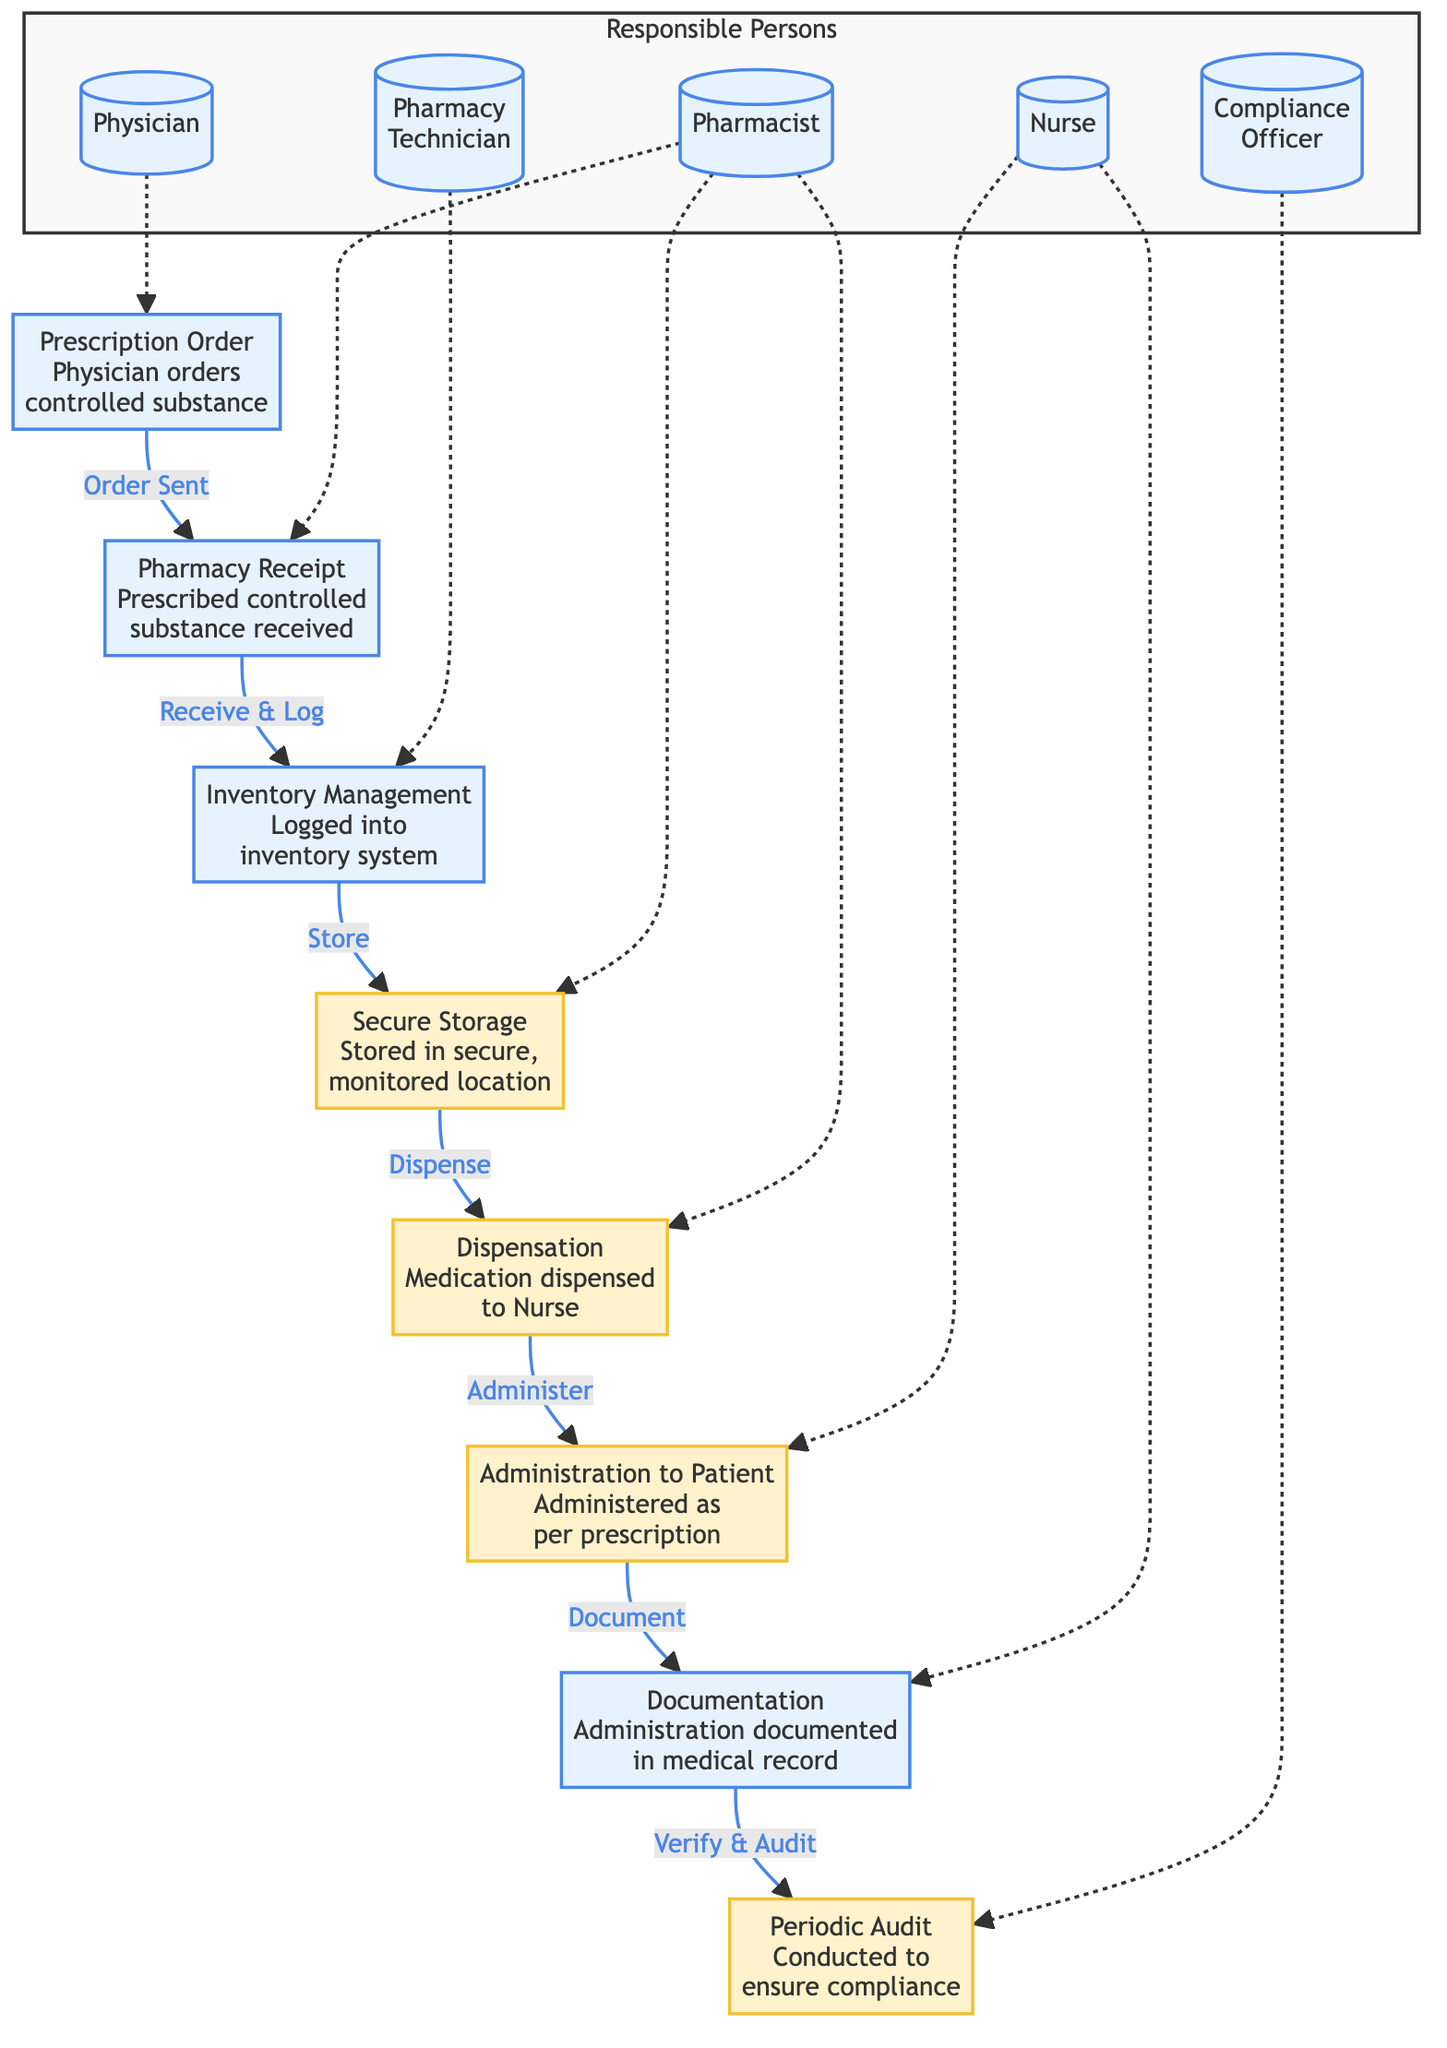What is the first step in the chain of custody? The first step in the chain of custody is the "Prescription Order," which occurs when a physician orders a controlled substance. This is indicated as the starting point in the diagram.
Answer: Prescription Order Who is responsible for the Pharmacy Receipt step? The "Pharmacy Receipt" step is indicated as being managed by the "Pharmacist" according to the responsible persons in the diagram.
Answer: Pharmacist How many nodes are in the diagram? By counting each distinct box in the provided diagram, there are a total of 8 nodes representing different steps in the chain of custody for controlled substances.
Answer: 8 What security measures are implemented during storage? The storage step is highlighted as "Secure Storage," indicating that the controlled substances are stored in a secure and monitored location, which is a security measure.
Answer: Stored in secure, monitored location Which step follows the Dispensation step? According to the flow of the diagram, after the "Dispensation" step, the next step is "Administration to Patient," where the medication is administered according to the prescription.
Answer: Administration to Patient Who conducts the audit? The "Compliance Officer" is tasked with conducting the periodic audits to ensure compliance, as listed under the responsible persons section of the diagram.
Answer: Compliance Officer Which two steps are linked by the phrase "Receive & Log"? The "Pharmacy Receipt" step and the "Inventory Management" step are connected by the phrase "Receive & Log," indicating that the pharmacist receives and logs the prescribed controlled substances into the inventory system.
Answer: Pharmacy Receipt and Inventory Management What is documented after the Administration step? After the "Administration to Patient" step, it is documented in the "Documentation" step that the administration has occurred for the medical record.
Answer: Documentation What type of person is responsible for the Inventory Management step? The "Inventory Management" step is handled by the "Pharmacy Technician," as indicated in the responsible persons section of the diagram.
Answer: Pharmacy Technician 